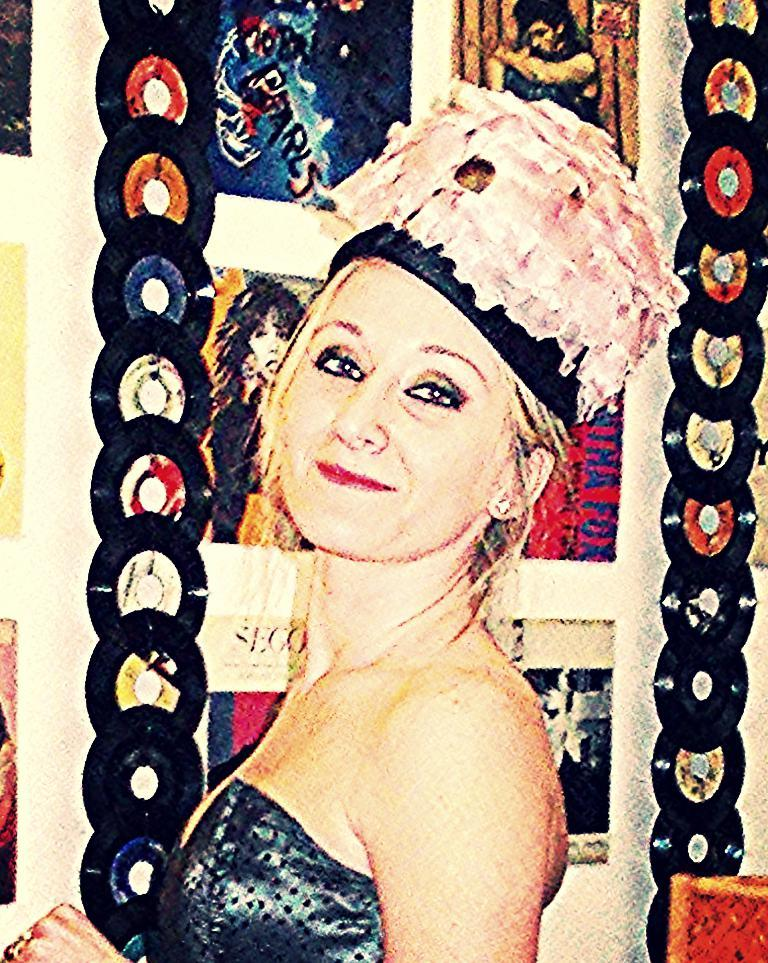What is the main subject of the image? There is a woman standing in the image. What can be seen in the background of the image? There are pictures and discs on the wall in the background. What type of umbrella is the woman holding in the image? There is no umbrella present in the image. Can you tell me how many frogs are on the discs in the image? There are no frogs depicted on the discs in the image. 